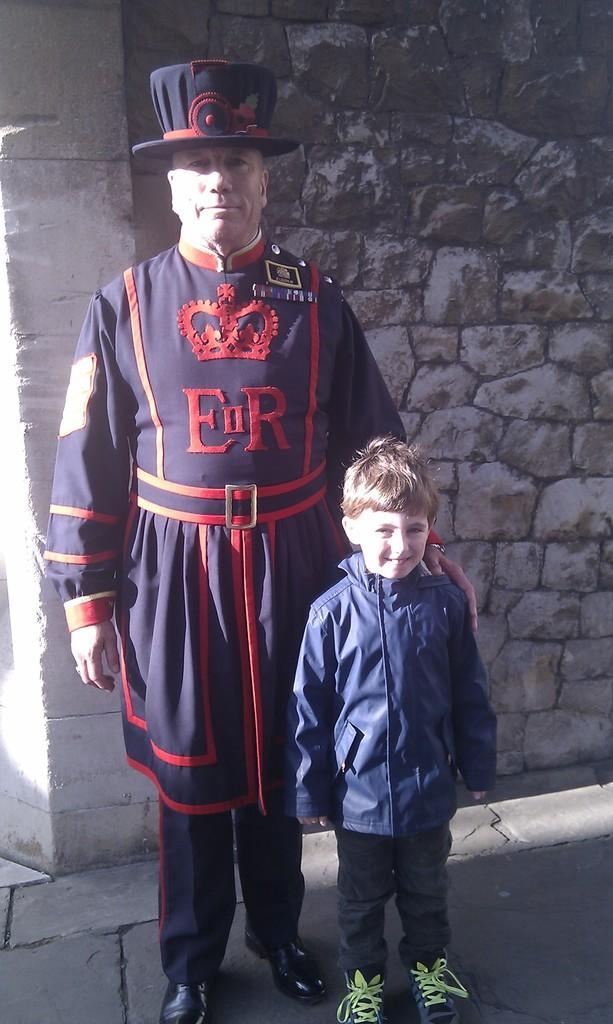Who is the main subject in the center of the image? There is a man and a boy standing in the center of the image. What can be seen behind the man and the boy? There is a wall in the background of the image. What is at the bottom of the image? There is a walkway at the bottom of the image. How many centimeters of air can be seen between the man and the boy in the image? There is no measurement of air provided in the image, and it is not possible to determine the distance between the man and the boy based on the given facts. 